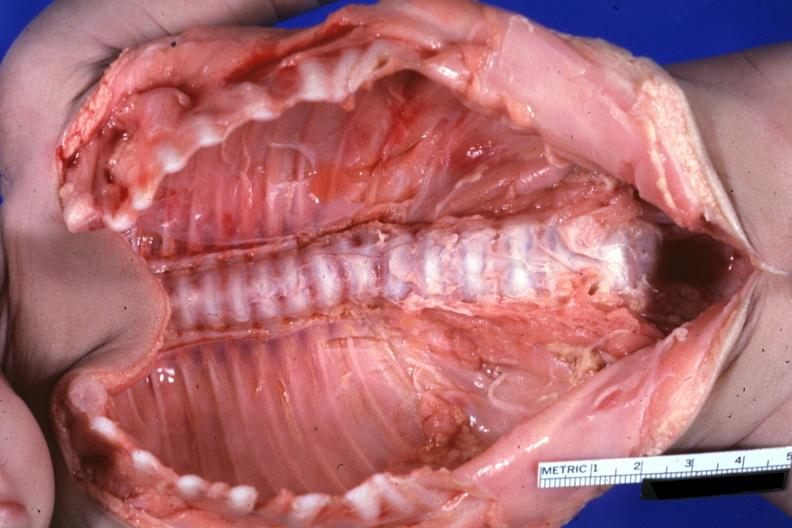s numerous atypical cells around splenic arteriole man present?
Answer the question using a single word or phrase. No 